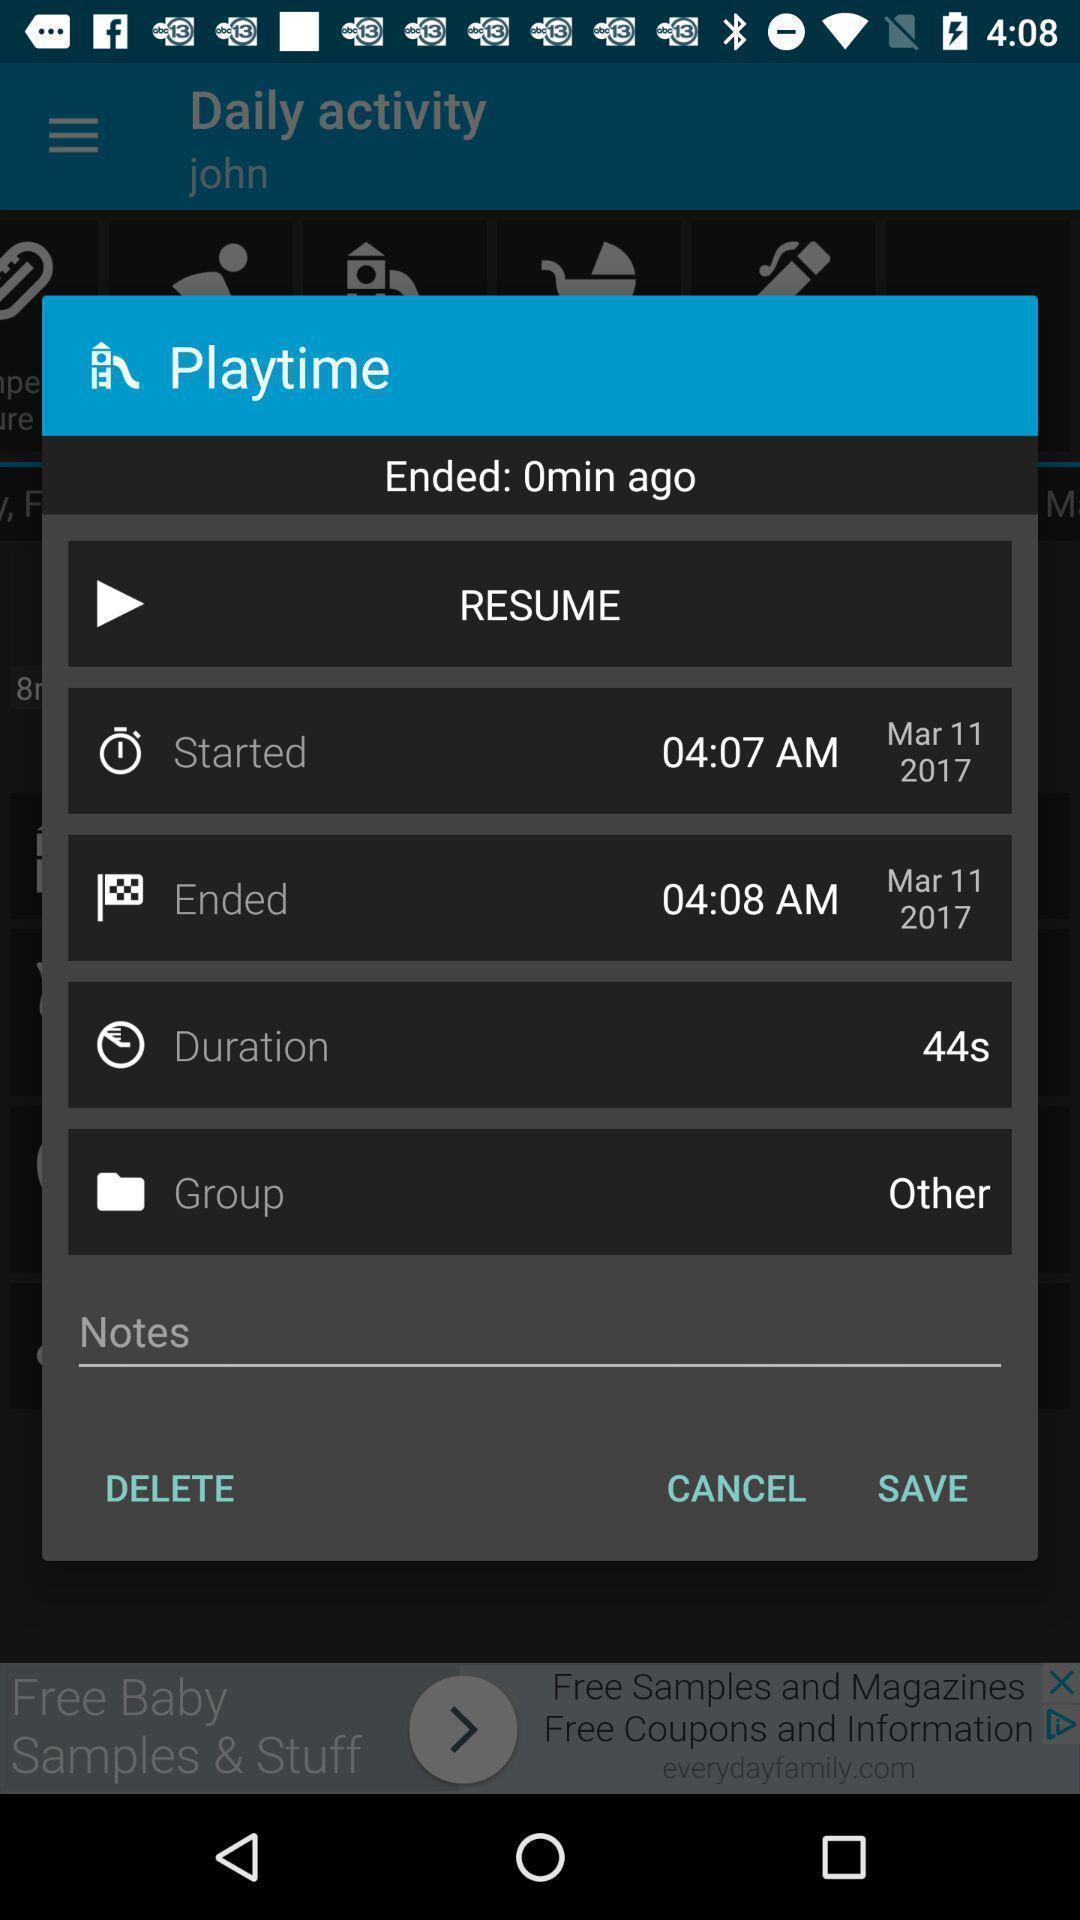Provide a textual representation of this image. Pop-up displaying to save a note in app. 